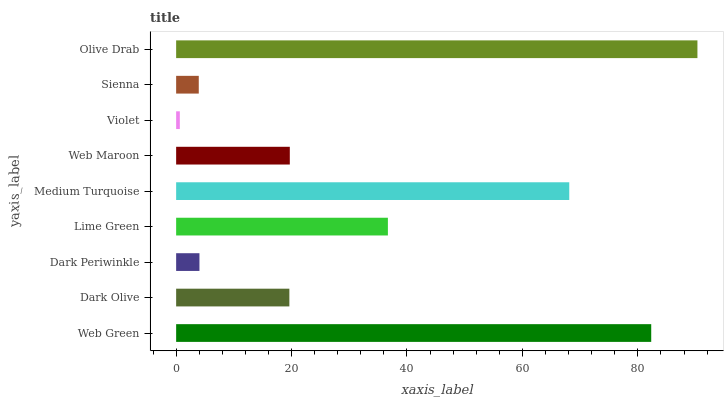Is Violet the minimum?
Answer yes or no. Yes. Is Olive Drab the maximum?
Answer yes or no. Yes. Is Dark Olive the minimum?
Answer yes or no. No. Is Dark Olive the maximum?
Answer yes or no. No. Is Web Green greater than Dark Olive?
Answer yes or no. Yes. Is Dark Olive less than Web Green?
Answer yes or no. Yes. Is Dark Olive greater than Web Green?
Answer yes or no. No. Is Web Green less than Dark Olive?
Answer yes or no. No. Is Web Maroon the high median?
Answer yes or no. Yes. Is Web Maroon the low median?
Answer yes or no. Yes. Is Medium Turquoise the high median?
Answer yes or no. No. Is Violet the low median?
Answer yes or no. No. 